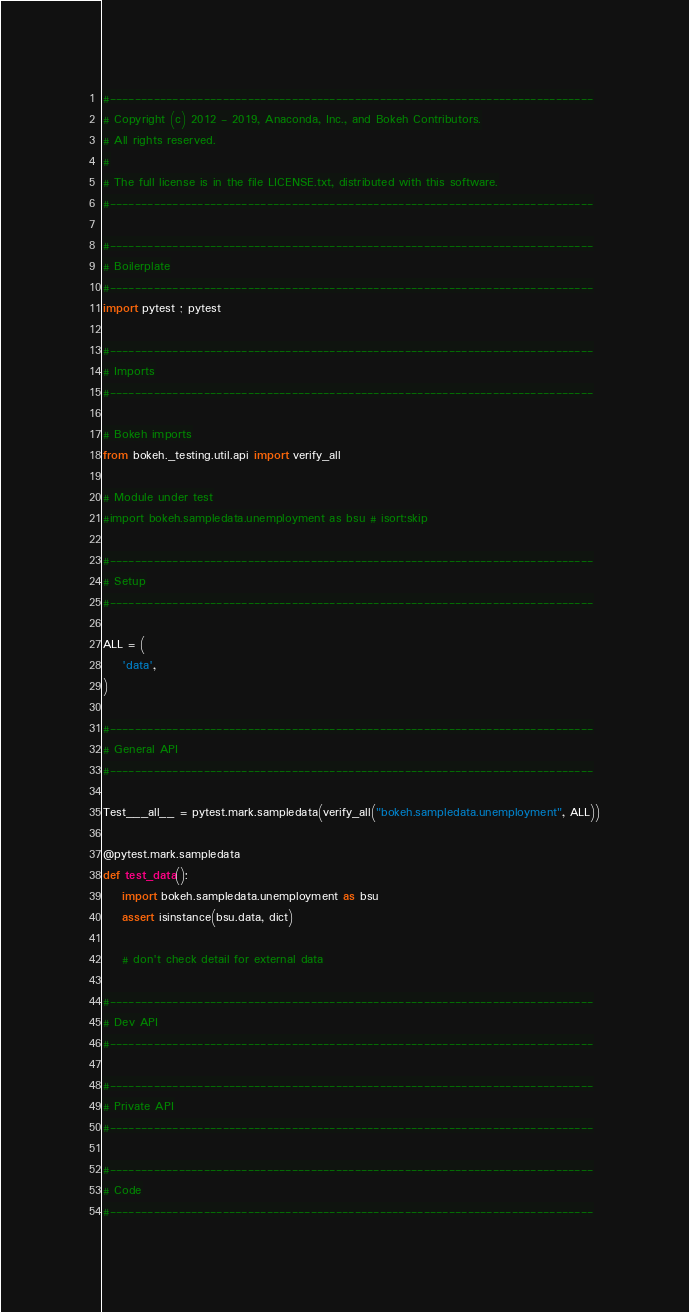Convert code to text. <code><loc_0><loc_0><loc_500><loc_500><_Python_>#-----------------------------------------------------------------------------
# Copyright (c) 2012 - 2019, Anaconda, Inc., and Bokeh Contributors.
# All rights reserved.
#
# The full license is in the file LICENSE.txt, distributed with this software.
#-----------------------------------------------------------------------------

#-----------------------------------------------------------------------------
# Boilerplate
#-----------------------------------------------------------------------------
import pytest ; pytest

#-----------------------------------------------------------------------------
# Imports
#-----------------------------------------------------------------------------

# Bokeh imports
from bokeh._testing.util.api import verify_all

# Module under test
#import bokeh.sampledata.unemployment as bsu # isort:skip

#-----------------------------------------------------------------------------
# Setup
#-----------------------------------------------------------------------------

ALL = (
    'data',
)

#-----------------------------------------------------------------------------
# General API
#-----------------------------------------------------------------------------

Test___all__ = pytest.mark.sampledata(verify_all("bokeh.sampledata.unemployment", ALL))

@pytest.mark.sampledata
def test_data():
    import bokeh.sampledata.unemployment as bsu
    assert isinstance(bsu.data, dict)

    # don't check detail for external data

#-----------------------------------------------------------------------------
# Dev API
#-----------------------------------------------------------------------------

#-----------------------------------------------------------------------------
# Private API
#-----------------------------------------------------------------------------

#-----------------------------------------------------------------------------
# Code
#-----------------------------------------------------------------------------
</code> 